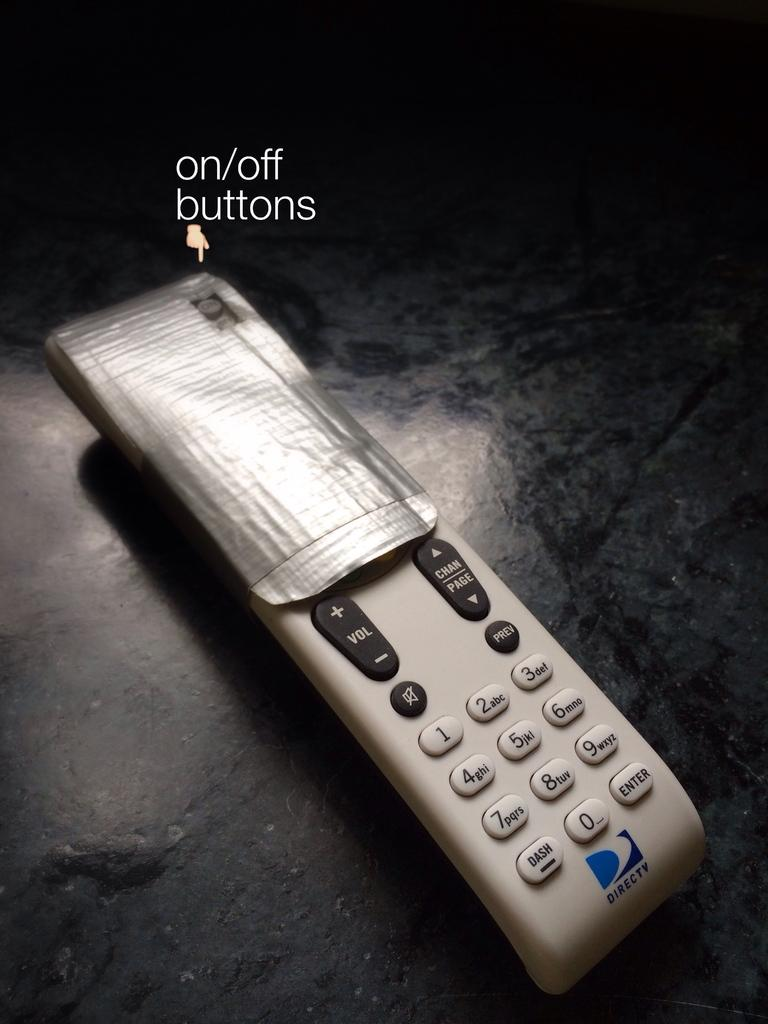<image>
Offer a succinct explanation of the picture presented. The remote on the table is made by DIrect TV. 